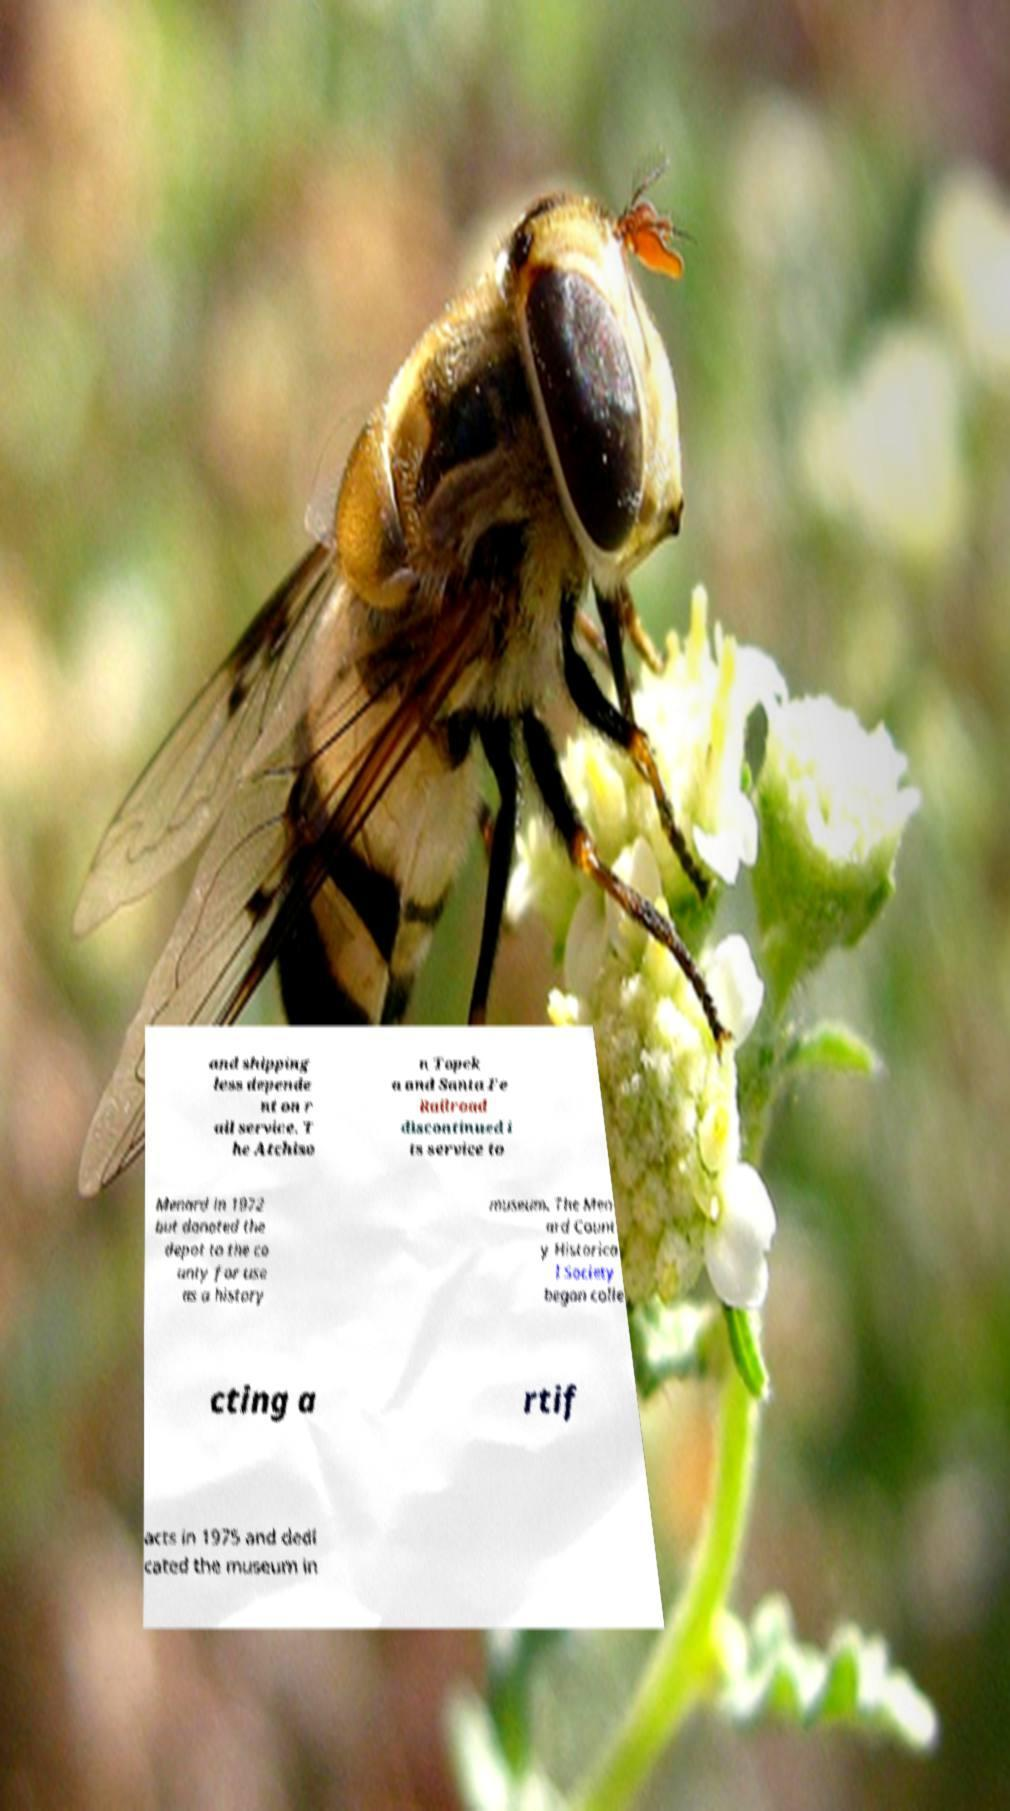Please identify and transcribe the text found in this image. and shipping less depende nt on r ail service. T he Atchiso n Topek a and Santa Fe Railroad discontinued i ts service to Menard in 1972 but donated the depot to the co unty for use as a history museum. The Men ard Count y Historica l Society began colle cting a rtif acts in 1975 and dedi cated the museum in 